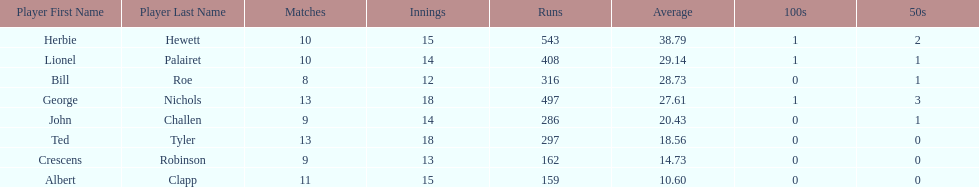Which player had the least amount of runs? Albert Clapp. 